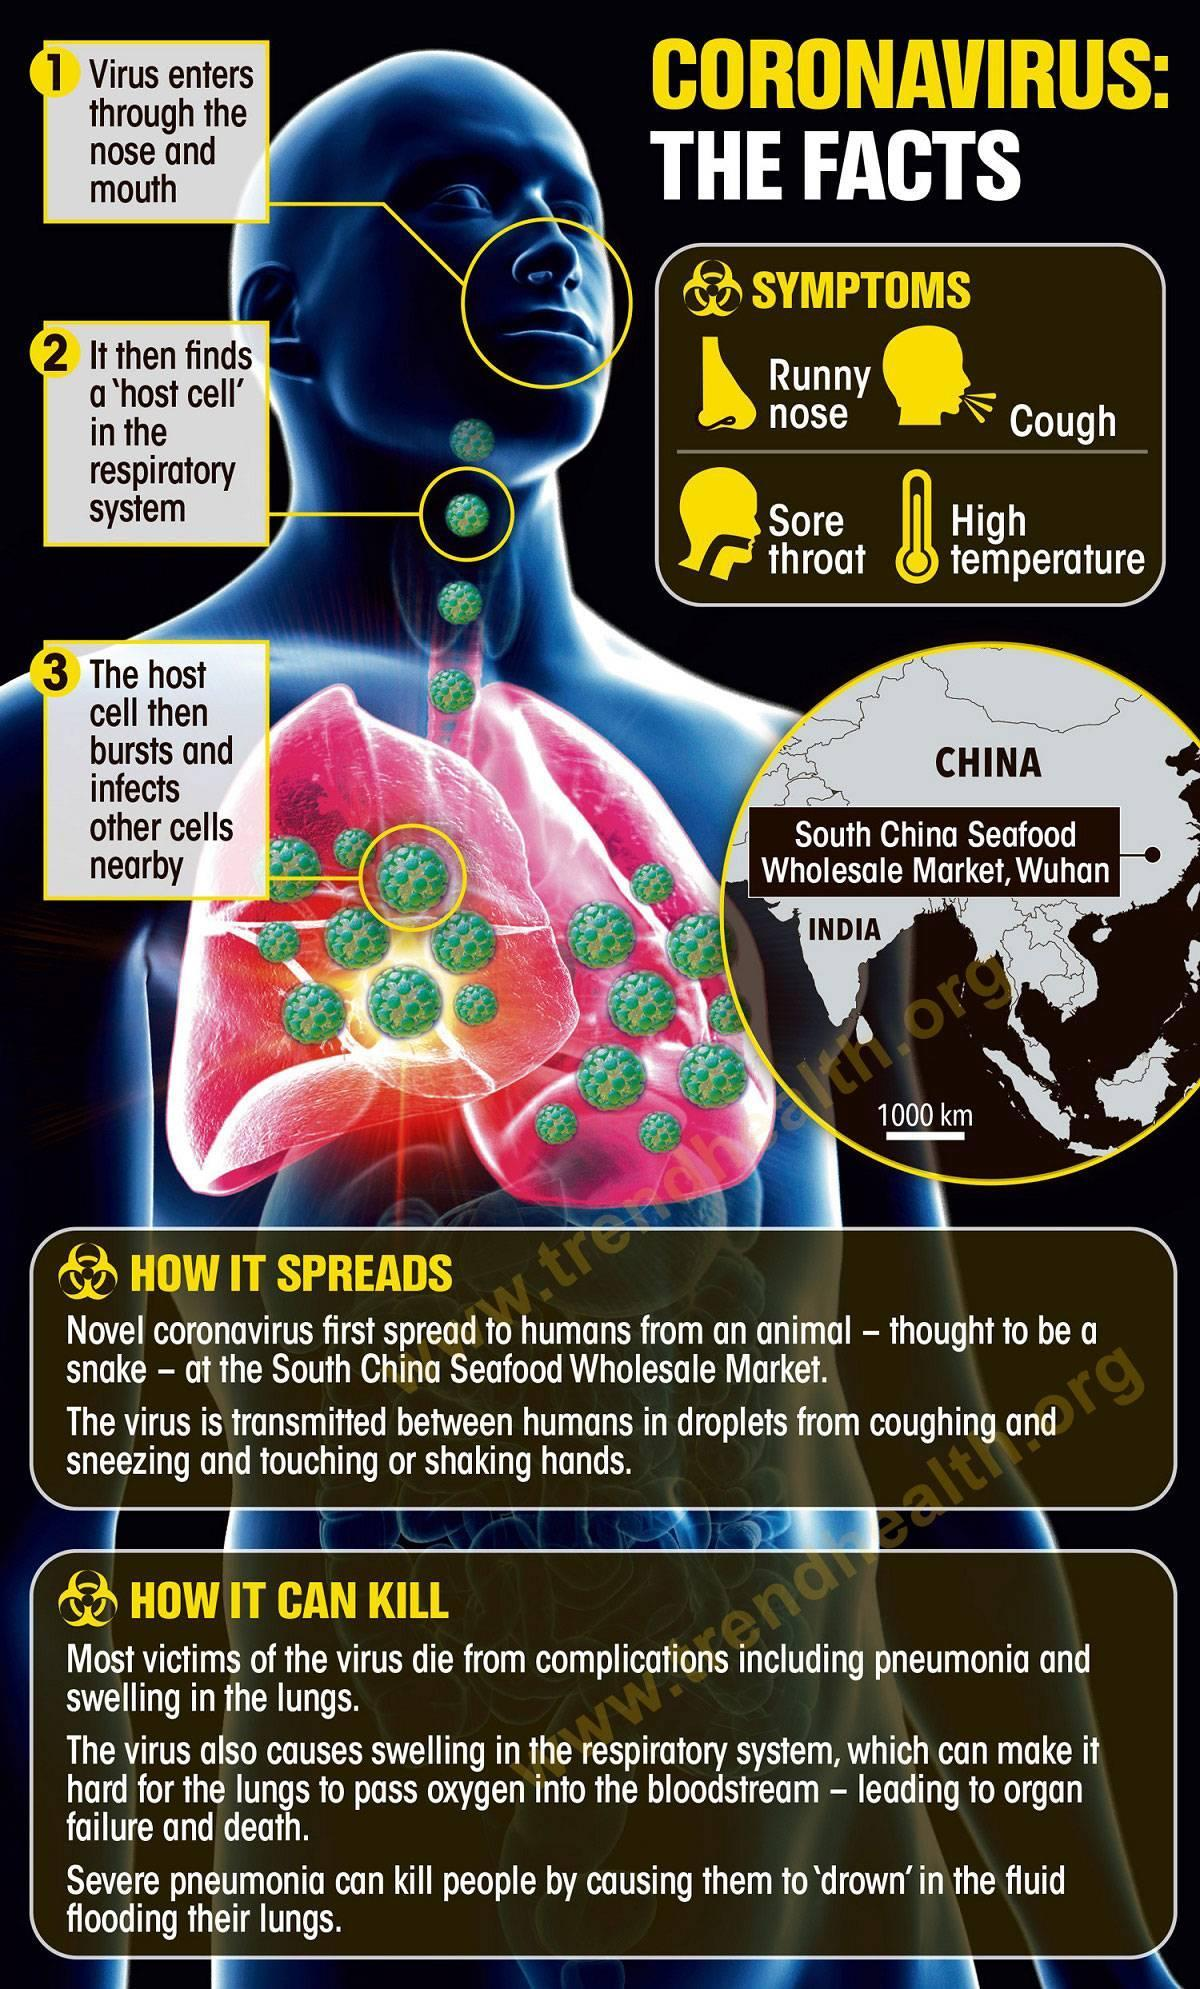How many symptoms are in this infographic?
Answer the question with a short phrase. 4 